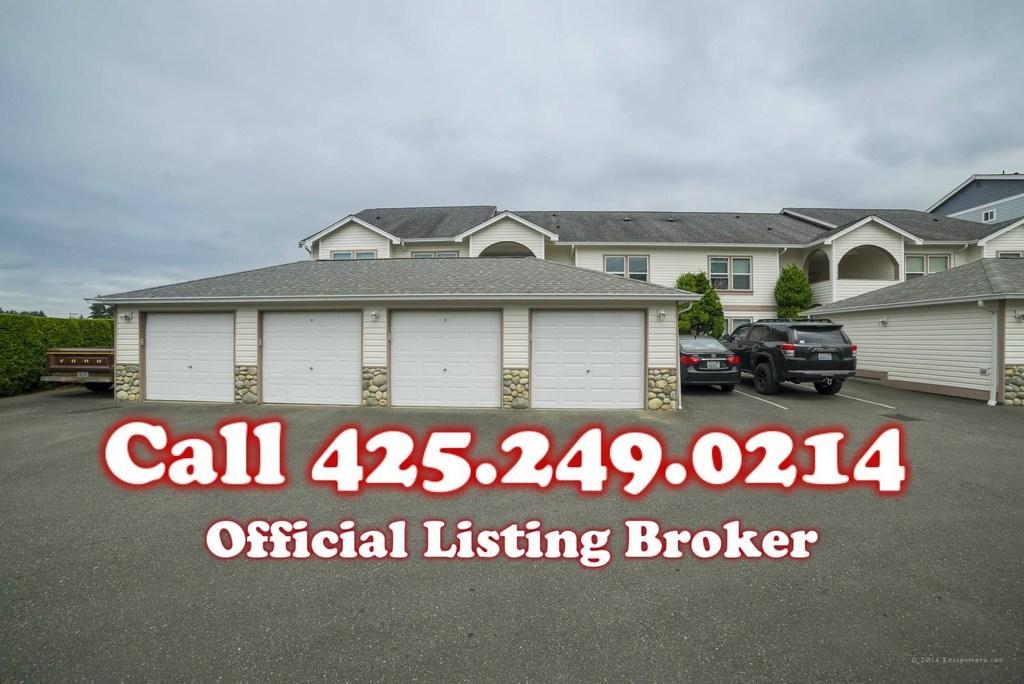Please provide a concise description of this image. This looks like a house with the windows. I can see two cars, which are parked. These are the trees. I can see small bushes. This is the watermark on the image. 